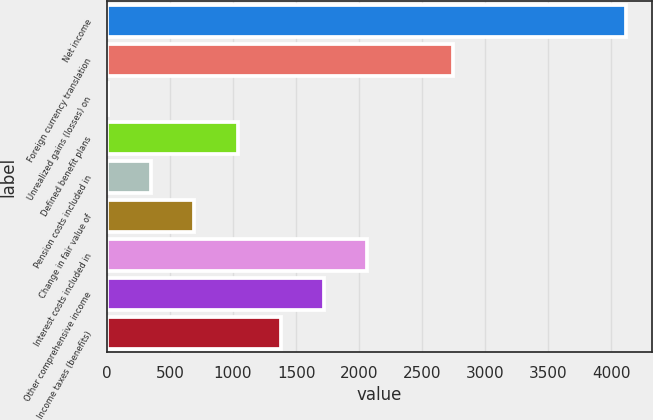<chart> <loc_0><loc_0><loc_500><loc_500><bar_chart><fcel>Net income<fcel>Foreign currency translation<fcel>Unrealized gains (losses) on<fcel>Defined benefit plans<fcel>Pension costs included in<fcel>Change in fair value of<fcel>Interest costs included in<fcel>Other comprehensive income<fcel>Income taxes (benefits)<nl><fcel>4116.6<fcel>2747.4<fcel>9<fcel>1035.9<fcel>351.3<fcel>693.6<fcel>2062.8<fcel>1720.5<fcel>1378.2<nl></chart> 